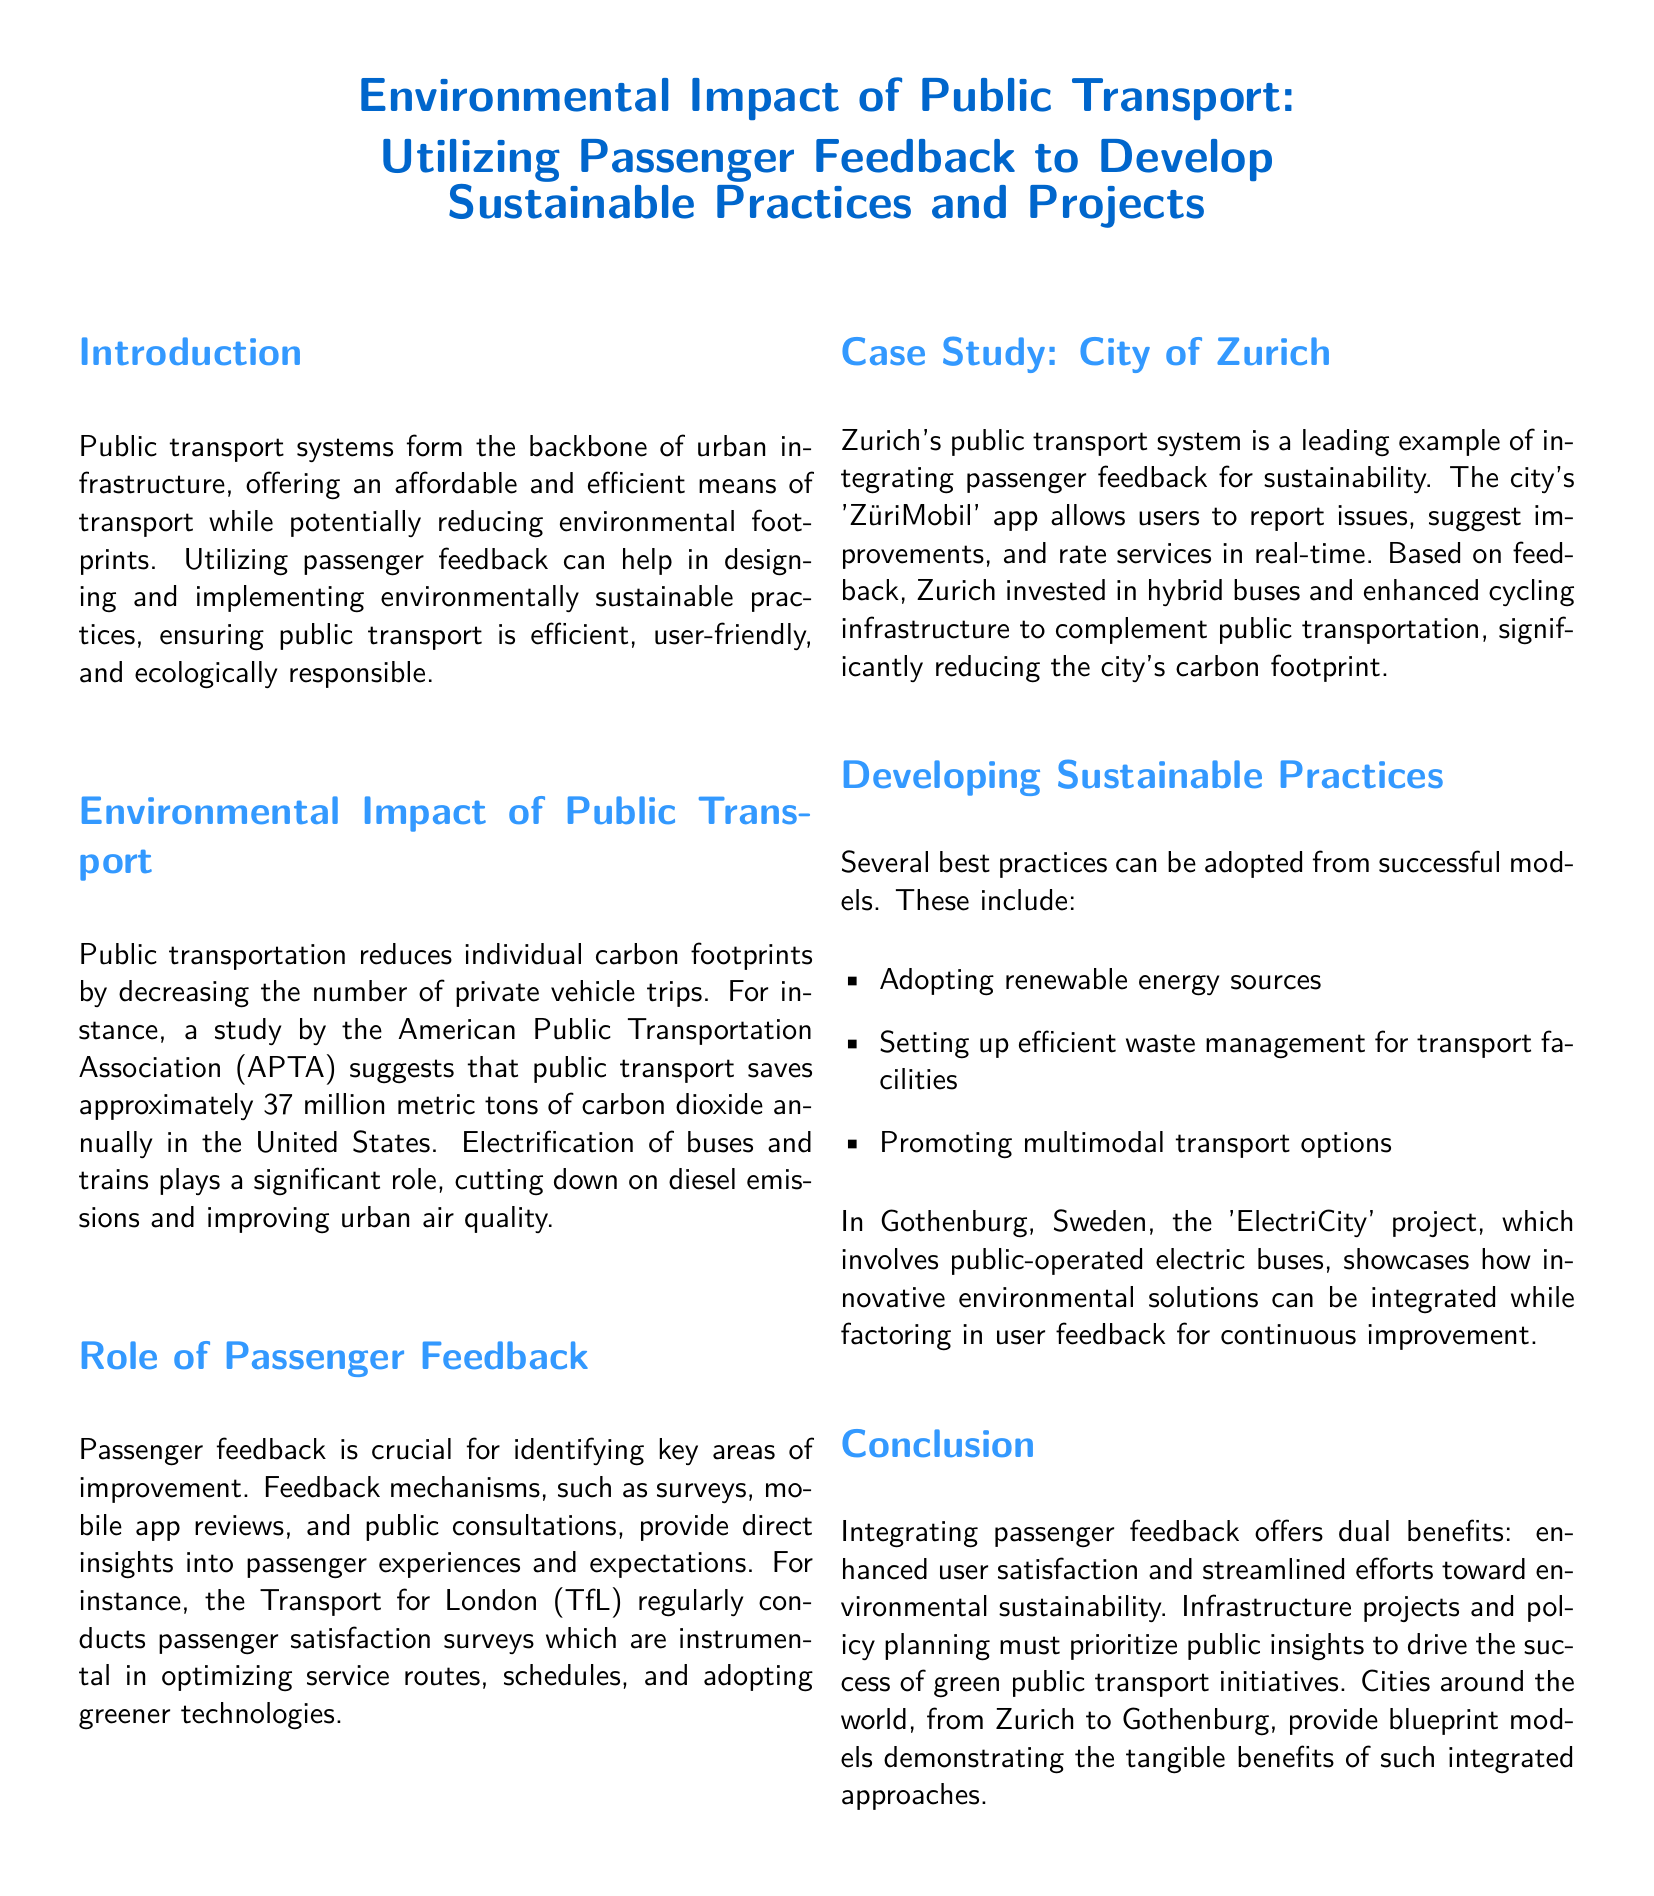what is the annual carbon dioxide saving in the United States due to public transport? According to the APTA, public transport saves approximately 37 million metric tons of carbon dioxide annually in the United States.
Answer: 37 million metric tons what app does Zurich use for passenger feedback? The document mentions that Zurich's public transport system utilizes the 'ZüriMobil' app for user feedback.
Answer: ZüriMobil what innovative project is mentioned in Gothenburg, Sweden? The document refers to the 'ElectriCity' project in Gothenburg, which involves public-operated electric buses.
Answer: ElectriCity how does passenger feedback help public transport systems? The document explains that passenger feedback is crucial for identifying key areas of improvement, optimizing services, and adopting greener technologies.
Answer: Identifying key areas of improvement what major benefit does integrating passenger feedback provide? The document highlights that integrating passenger feedback leads to enhanced user satisfaction and streamlined efforts toward environmental sustainability.
Answer: Enhanced user satisfaction what type of energy sources should be adopted for sustainable practices? The document states that adopting renewable energy sources is one of the best practices for sustainability in public transport.
Answer: Renewable energy sources 